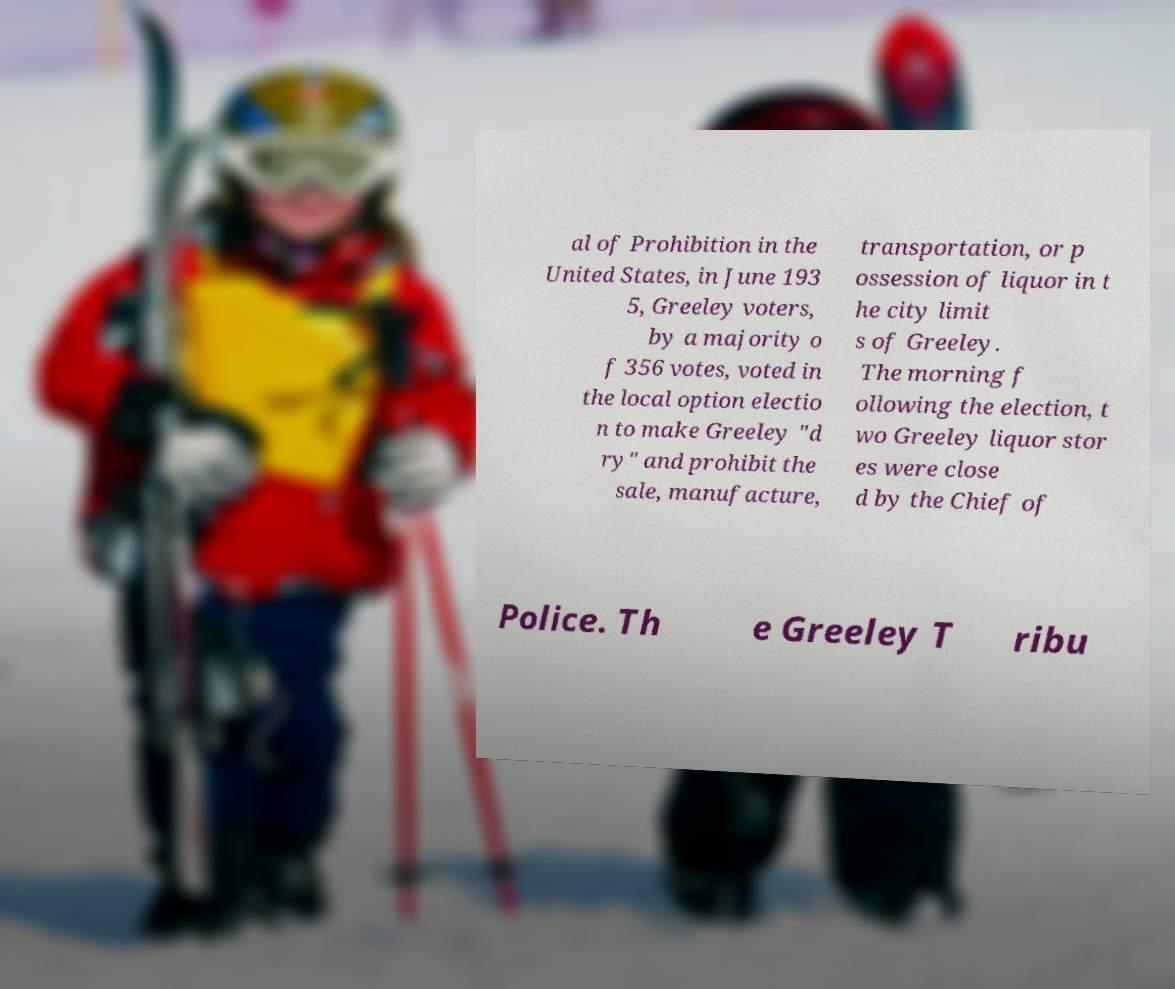I need the written content from this picture converted into text. Can you do that? al of Prohibition in the United States, in June 193 5, Greeley voters, by a majority o f 356 votes, voted in the local option electio n to make Greeley "d ry" and prohibit the sale, manufacture, transportation, or p ossession of liquor in t he city limit s of Greeley. The morning f ollowing the election, t wo Greeley liquor stor es were close d by the Chief of Police. Th e Greeley T ribu 